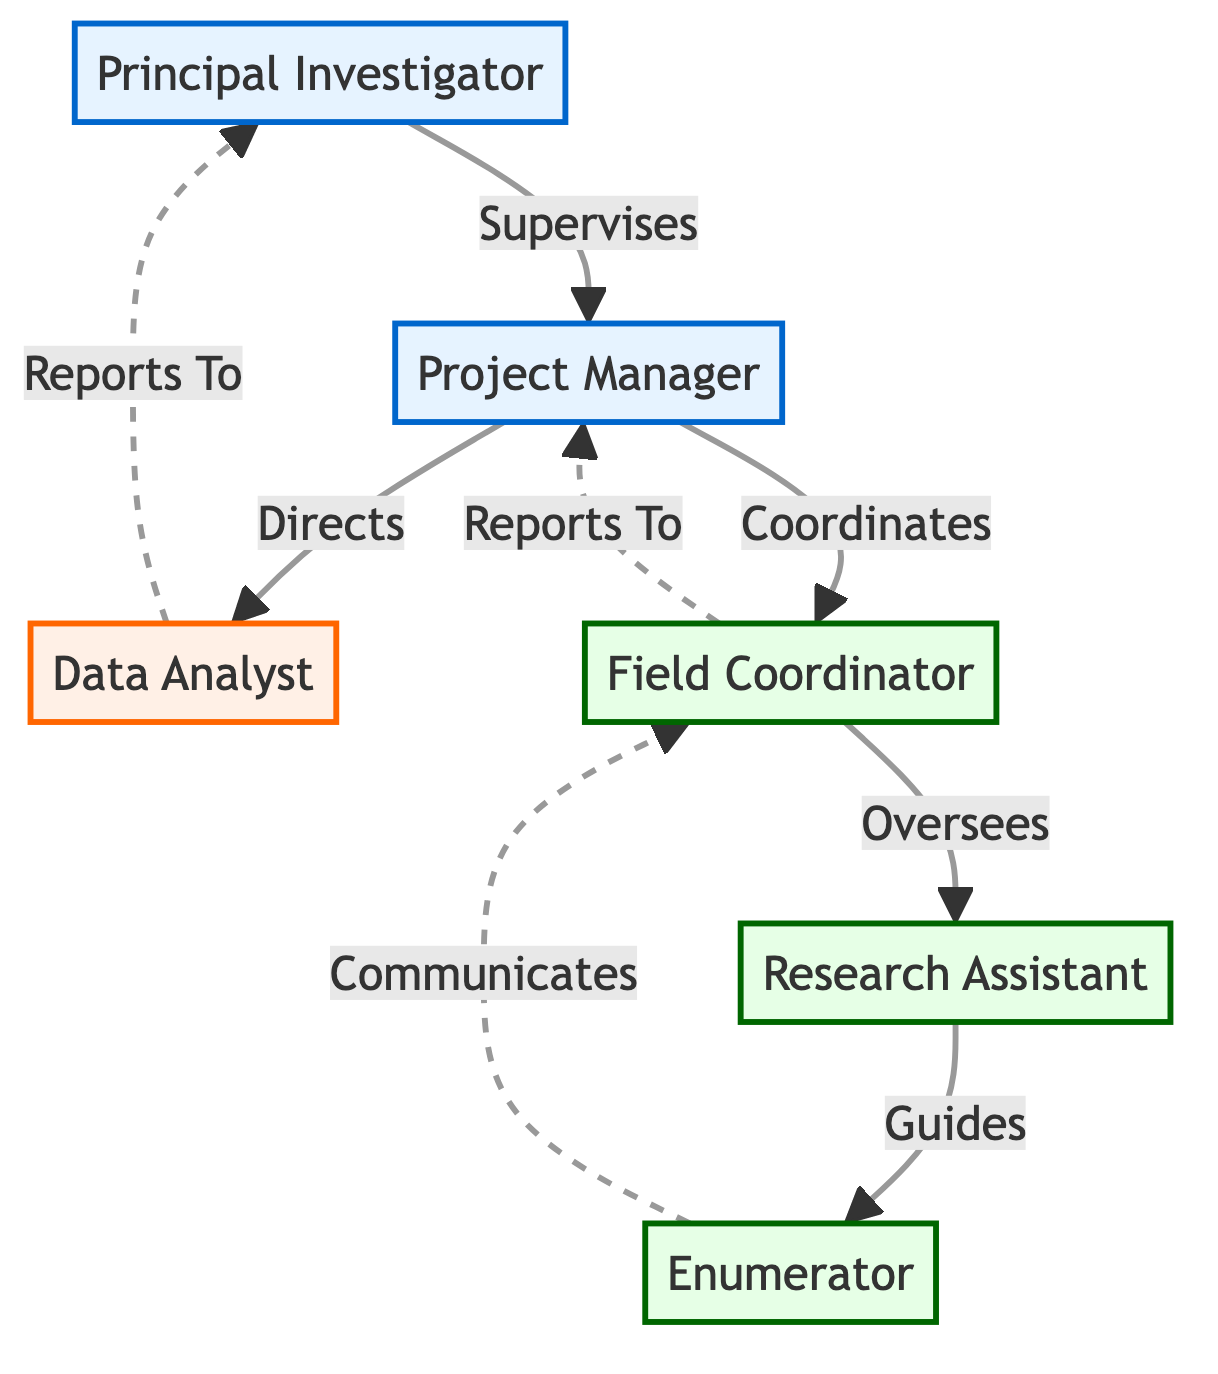What is the role of the PI? The Principal Investigator (PI) is labeled in the diagram and is the top node, which indicates that they supervise the Project Manager (PM).
Answer: Supervises How many nodes are there in the diagram? By counting the nodes for the roles, we see that there are six distinct roles: PI, PM, DA, FC, RA, and EN.
Answer: Six Who does the Field Coordinator oversee? The Field Coordinator (FC) connects to the Research Assistant (RA) through the "Oversees" relationship, indicating that the FC has authority over the RA.
Answer: RA What type of communication occurs between the Enumerator and the Field Coordinator? The Enumerator (EN) communicates with the Field Coordinator (FC) as shown by the direct line labeled "Communicates," indicating a straightforward line of communication.
Answer: Communicates Which role reports to the Project Manager? The diagram shows a direct line from the Field Coordinator (FC) to the Project Manager (PM) with the label "Reports To," meaning that the FC is the one reporting to the PM.
Answer: FC What is the relationship between the Data Analyst and the Principal Investigator? The relationship is indicated by a dashed line labeled "Reports To," which signifies that the Data Analyst (DA) submits reports to the Principal Investigator (PI), showing a reporting relationship.
Answer: Reports To How many roles are classified as field positions? In the diagram, the roles classified as field positions include the Field Coordinator (FC), Research Assistant (RA), and Enumerator (EN), thus totaling three field positions.
Answer: Three What type of line indicates reporting relationships in the diagram? The diagram uses a dashed line to represent relationships based on reporting; specifically, it indicates lines of reporting to higher roles, such as the Data Analyst to the Principal Investigator.
Answer: Dashed line Which role directs the Data Analyst? The diagram shows an arrow pointing from the Project Manager (PM) to the Data Analyst (DA), indicating that the PM directs the work of the DA.
Answer: PM 